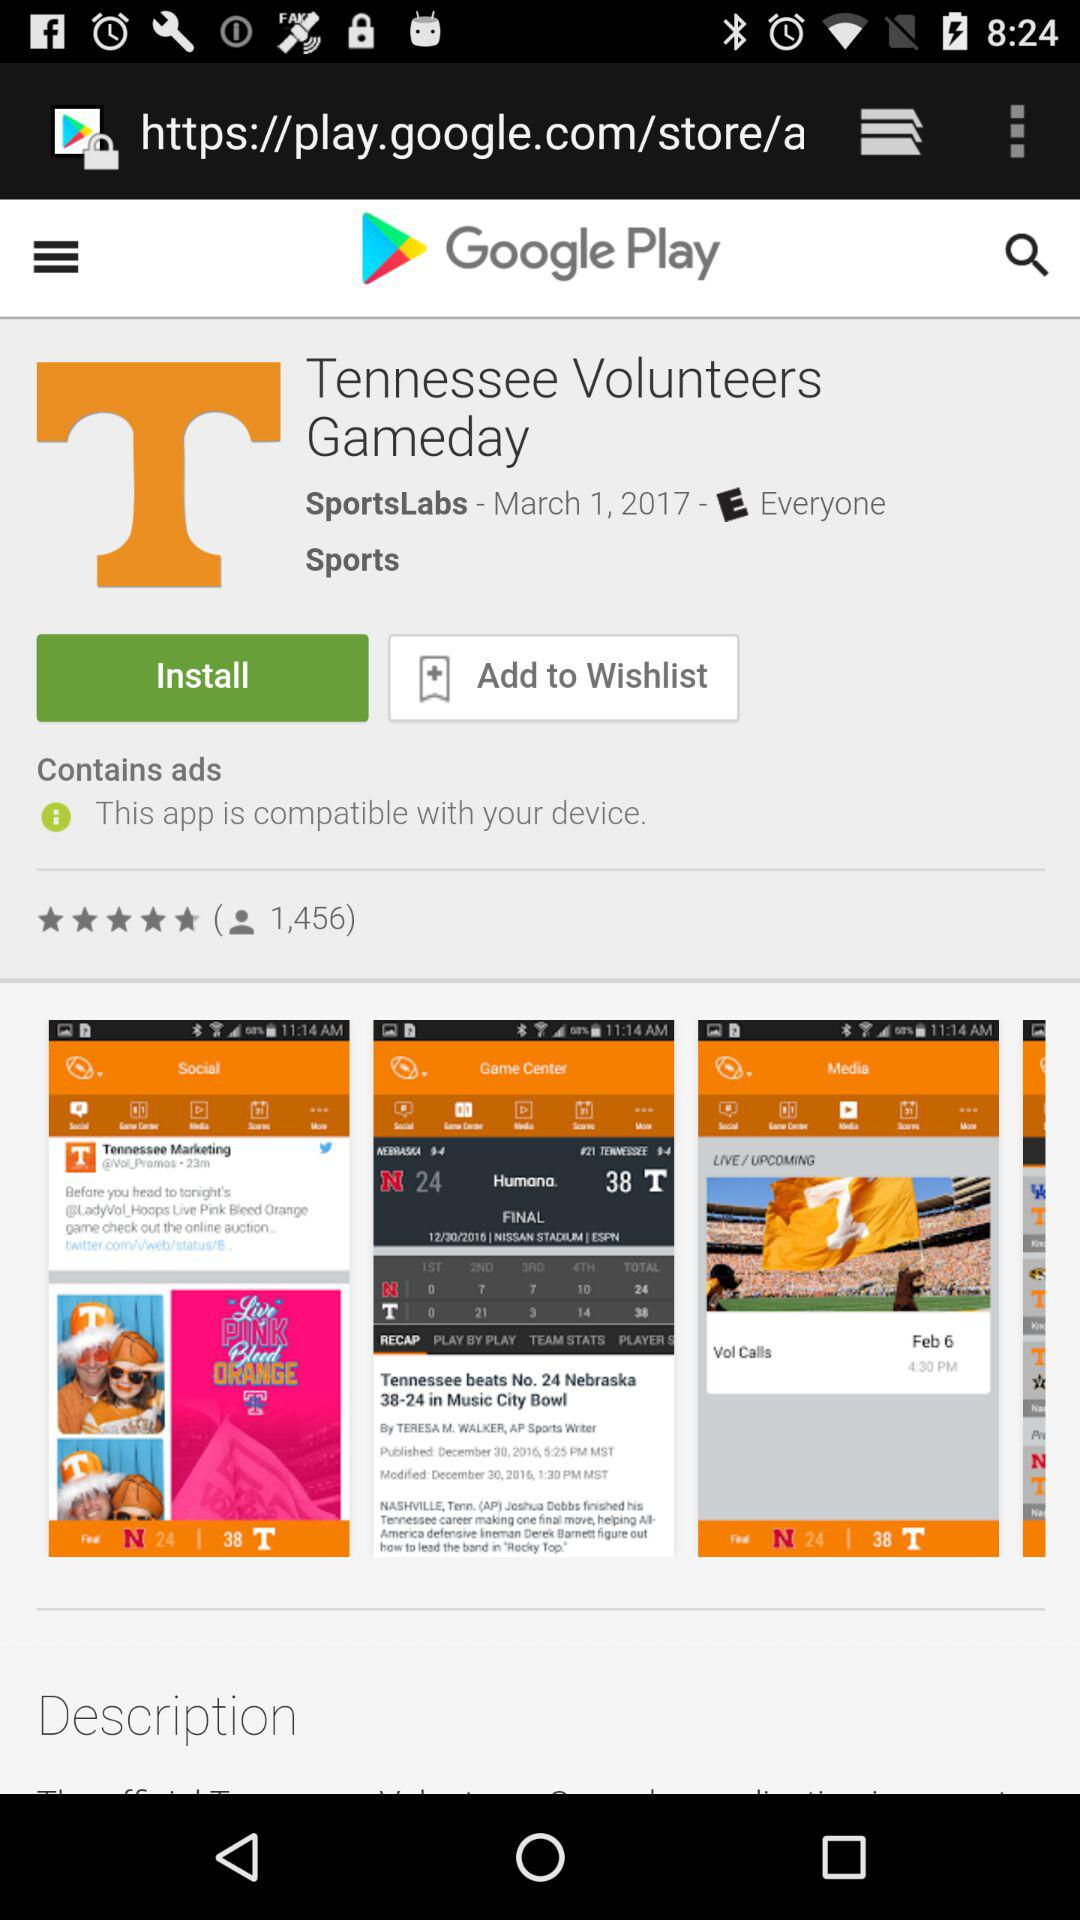What is the date? The date is March 1, 2017. 